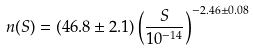<formula> <loc_0><loc_0><loc_500><loc_500>n ( S ) = ( 4 6 . 8 \pm 2 . 1 ) \left ( \frac { S } { 1 0 ^ { - 1 4 } } \right ) ^ { - 2 . 4 6 \pm 0 . 0 8 }</formula> 